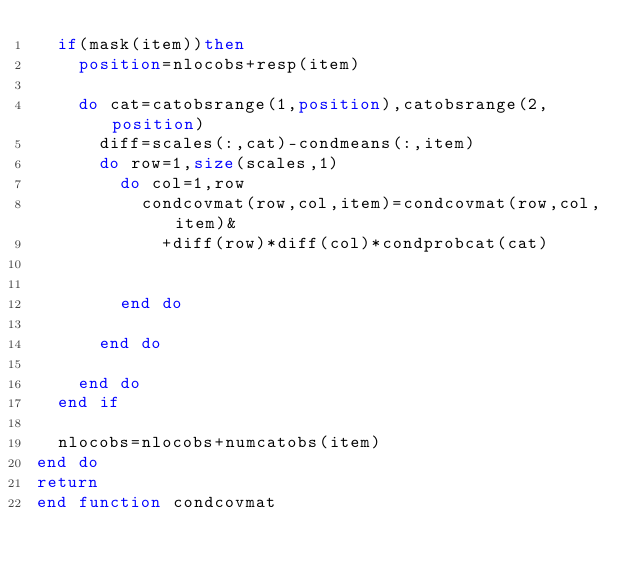<code> <loc_0><loc_0><loc_500><loc_500><_FORTRAN_>	if(mask(item))then
		position=nlocobs+resp(item)
	
		do cat=catobsrange(1,position),catobsrange(2,position)
			diff=scales(:,cat)-condmeans(:,item)
			do row=1,size(scales,1)
				do col=1,row
					condcovmat(row,col,item)=condcovmat(row,col,item)&
						+diff(row)*diff(col)*condprobcat(cat)
					
					
				end do
				
			end do
			
		end do
	end if

	nlocobs=nlocobs+numcatobs(item)
end do
return
end function condcovmat
</code> 